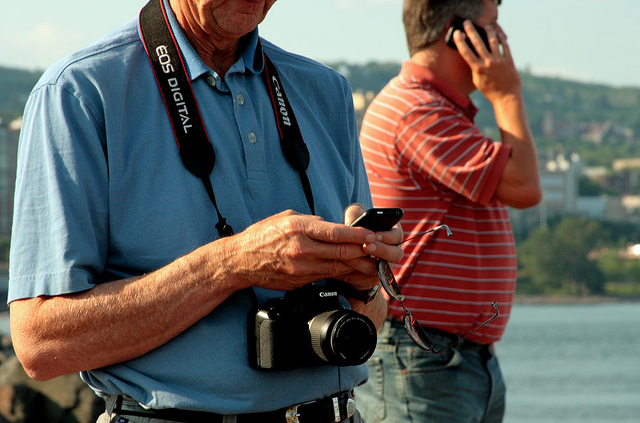What does the man do with the object around his neck?
A. paint
B. take photos
C. call
D. text
Answer with the option's letter from the given choices directly. B 